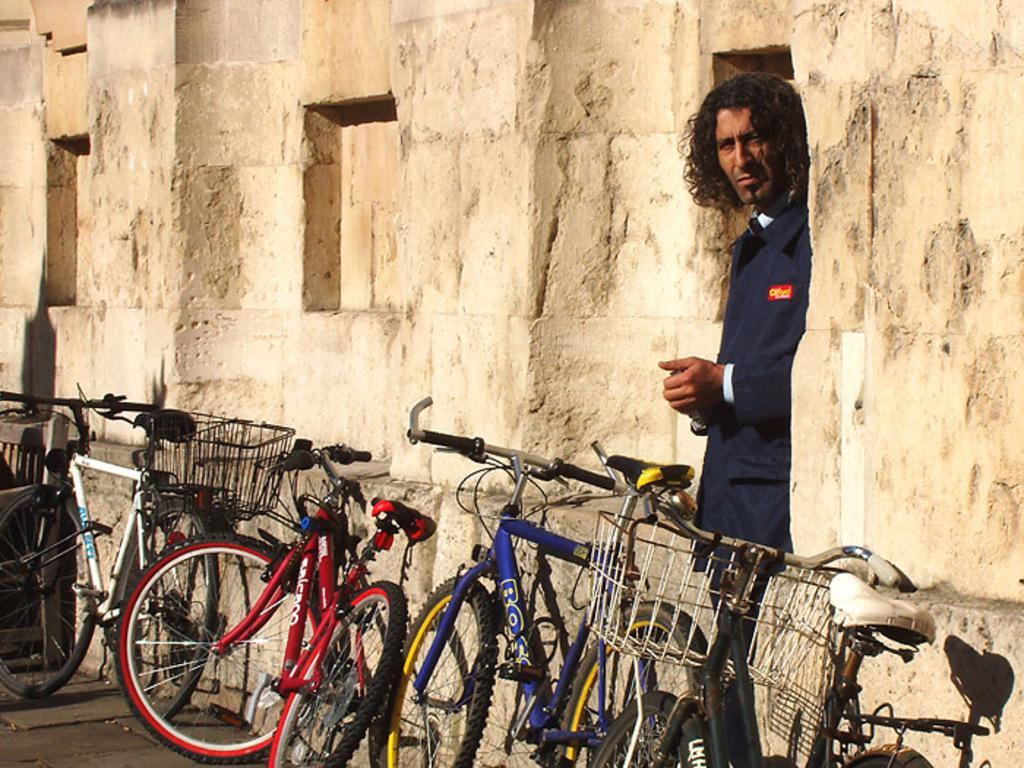What can be seen on the road in the image? There are bicycles on the road in the image. What is the man in the image doing? The man is standing on the floor in the image. What material is used to build the wall in the image? The wall in the image is built with cobblestones. What type of chalk is being used to draw on the wall in the image? There is no chalk or drawing present on the wall in the image; it is built with cobblestones. How does the man in the image use the brush to clean the bicycles? There is no brush or cleaning activity depicted in the image; the man is simply standing on the floor. 